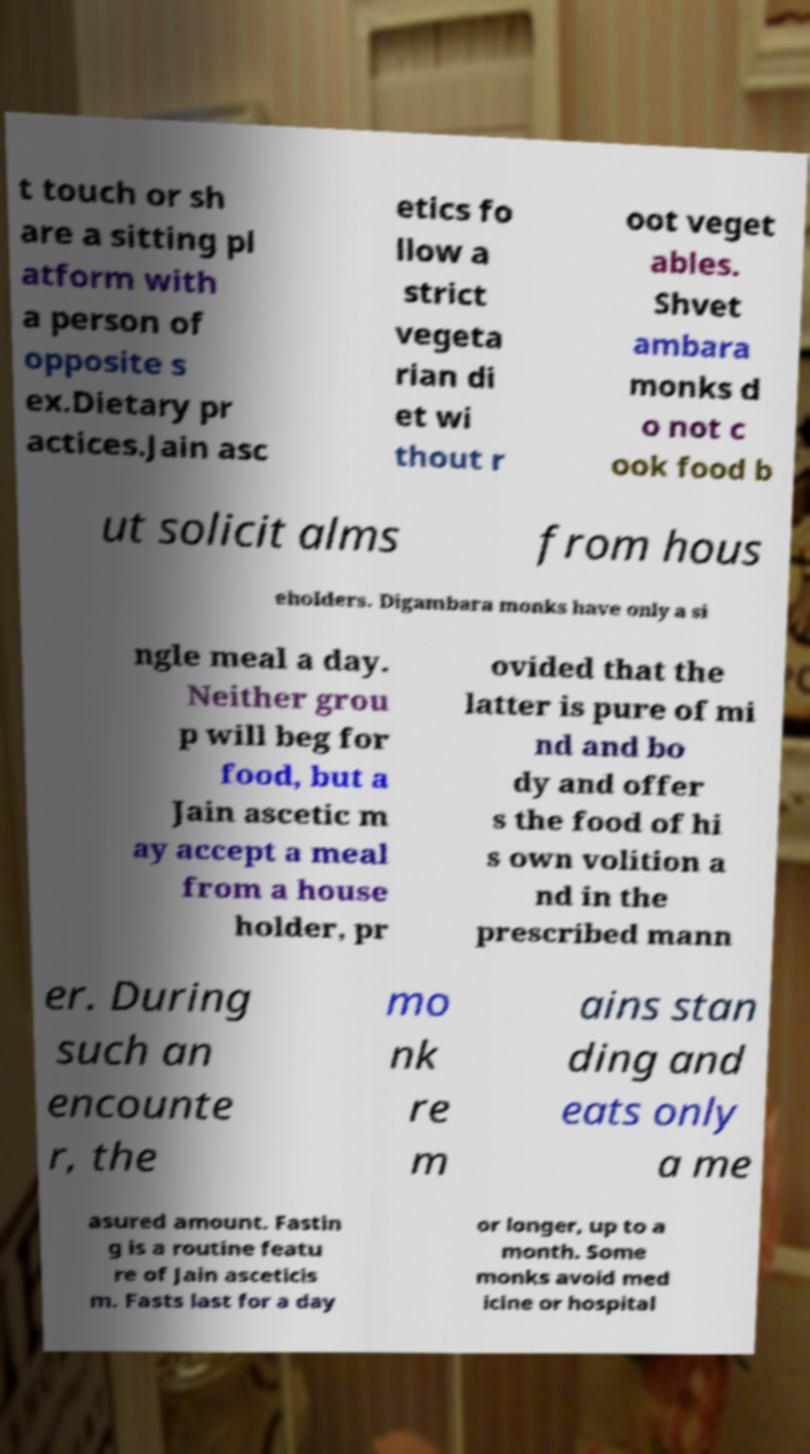Can you accurately transcribe the text from the provided image for me? t touch or sh are a sitting pl atform with a person of opposite s ex.Dietary pr actices.Jain asc etics fo llow a strict vegeta rian di et wi thout r oot veget ables. Shvet ambara monks d o not c ook food b ut solicit alms from hous eholders. Digambara monks have only a si ngle meal a day. Neither grou p will beg for food, but a Jain ascetic m ay accept a meal from a house holder, pr ovided that the latter is pure of mi nd and bo dy and offer s the food of hi s own volition a nd in the prescribed mann er. During such an encounte r, the mo nk re m ains stan ding and eats only a me asured amount. Fastin g is a routine featu re of Jain asceticis m. Fasts last for a day or longer, up to a month. Some monks avoid med icine or hospital 